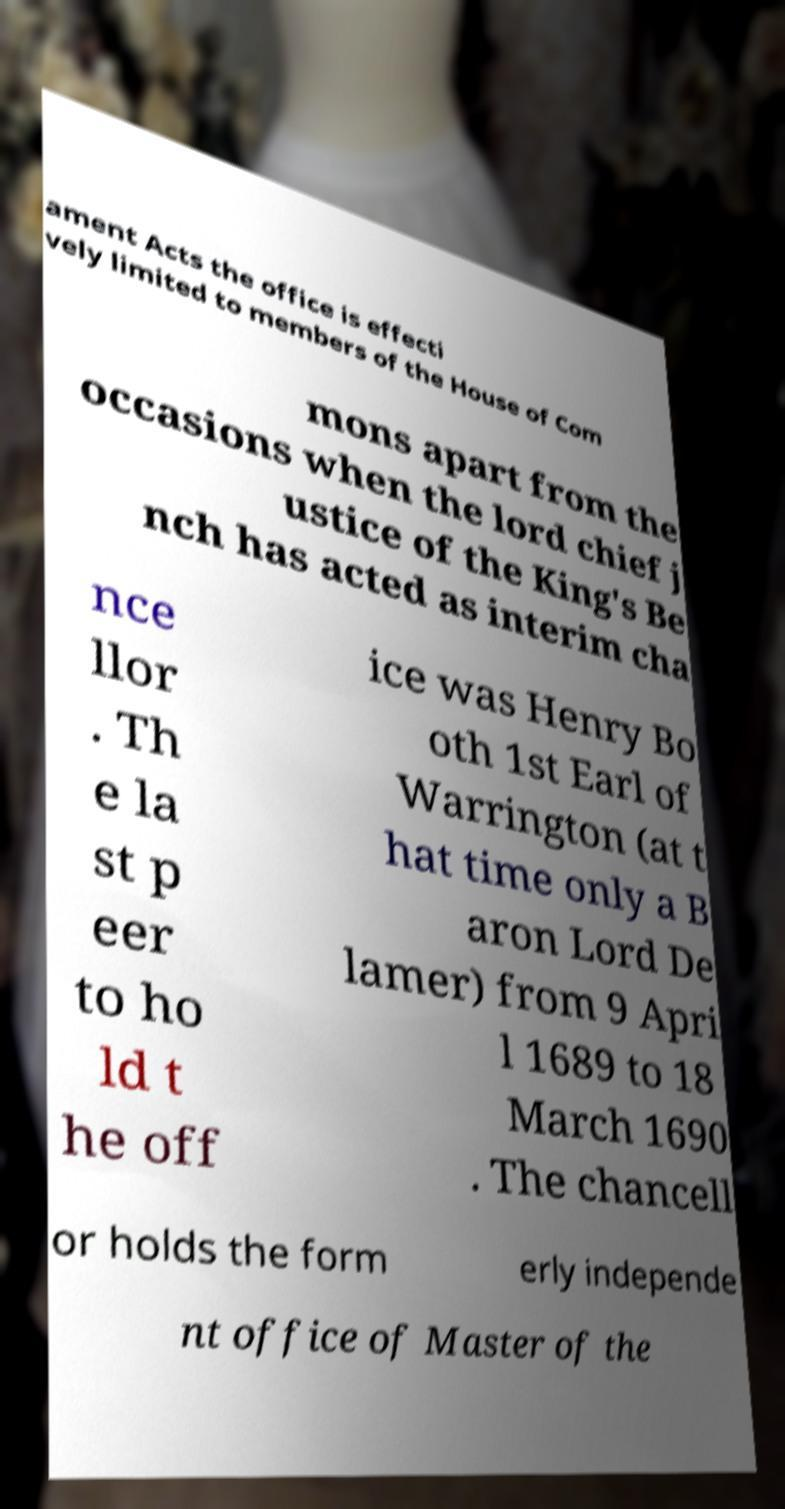Can you accurately transcribe the text from the provided image for me? ament Acts the office is effecti vely limited to members of the House of Com mons apart from the occasions when the lord chief j ustice of the King's Be nch has acted as interim cha nce llor . Th e la st p eer to ho ld t he off ice was Henry Bo oth 1st Earl of Warrington (at t hat time only a B aron Lord De lamer) from 9 Apri l 1689 to 18 March 1690 . The chancell or holds the form erly independe nt office of Master of the 